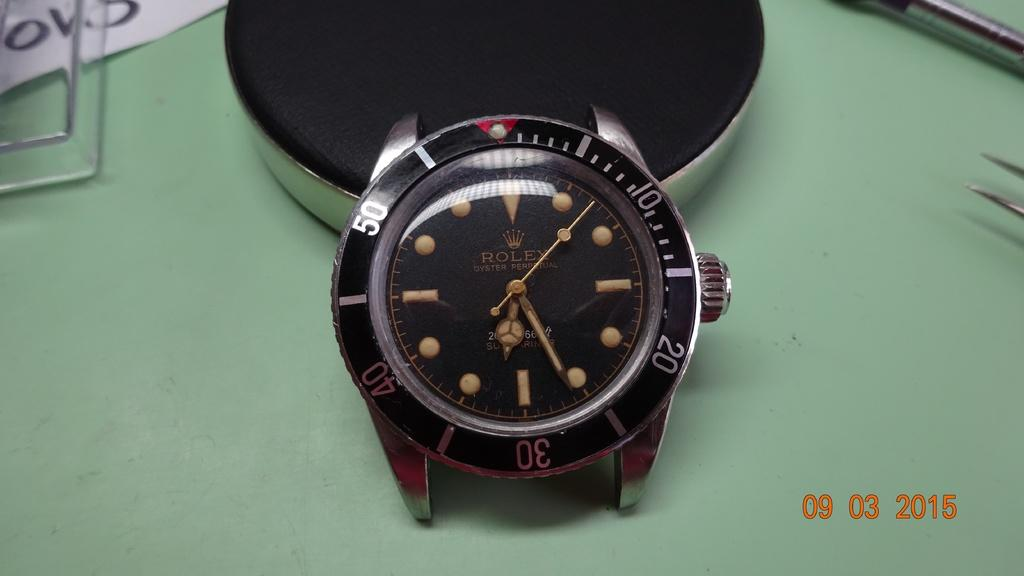<image>
Present a compact description of the photo's key features. The Rolex watch does not have a wrist band. 